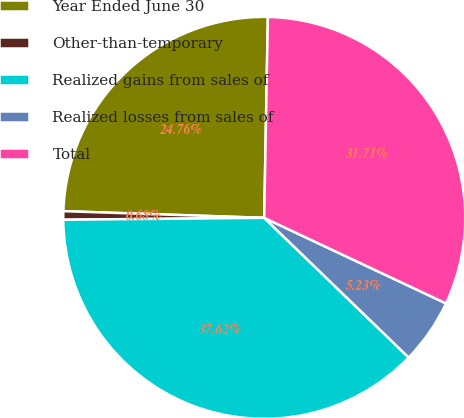Convert chart. <chart><loc_0><loc_0><loc_500><loc_500><pie_chart><fcel>Year Ended June 30<fcel>Other-than-temporary<fcel>Realized gains from sales of<fcel>Realized losses from sales of<fcel>Total<nl><fcel>24.76%<fcel>0.68%<fcel>37.62%<fcel>5.23%<fcel>31.71%<nl></chart> 